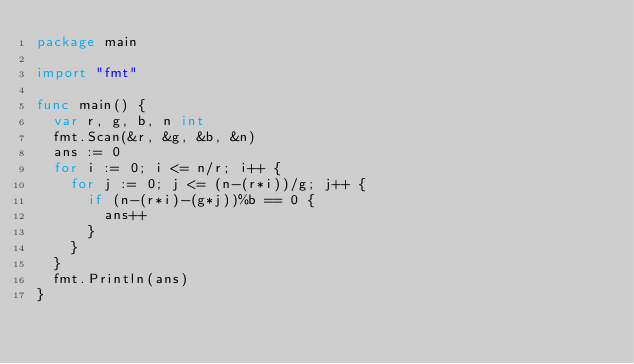<code> <loc_0><loc_0><loc_500><loc_500><_Go_>package main

import "fmt"

func main() {
	var r, g, b, n int
	fmt.Scan(&r, &g, &b, &n)
	ans := 0
	for i := 0; i <= n/r; i++ {
		for j := 0; j <= (n-(r*i))/g; j++ {
			if (n-(r*i)-(g*j))%b == 0 {
				ans++
			}
		}
	}
	fmt.Println(ans)
}
</code> 